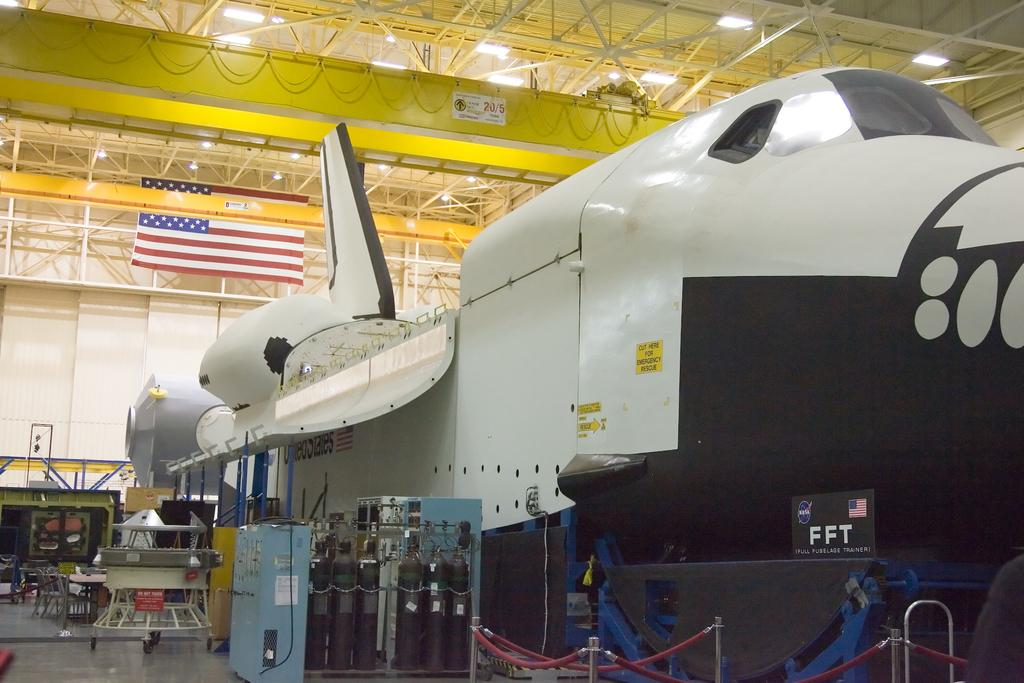<image>
Give a short and clear explanation of the subsequent image. An airplane in a hanger with the letters FFT on the bottom of it next to an American flag. 